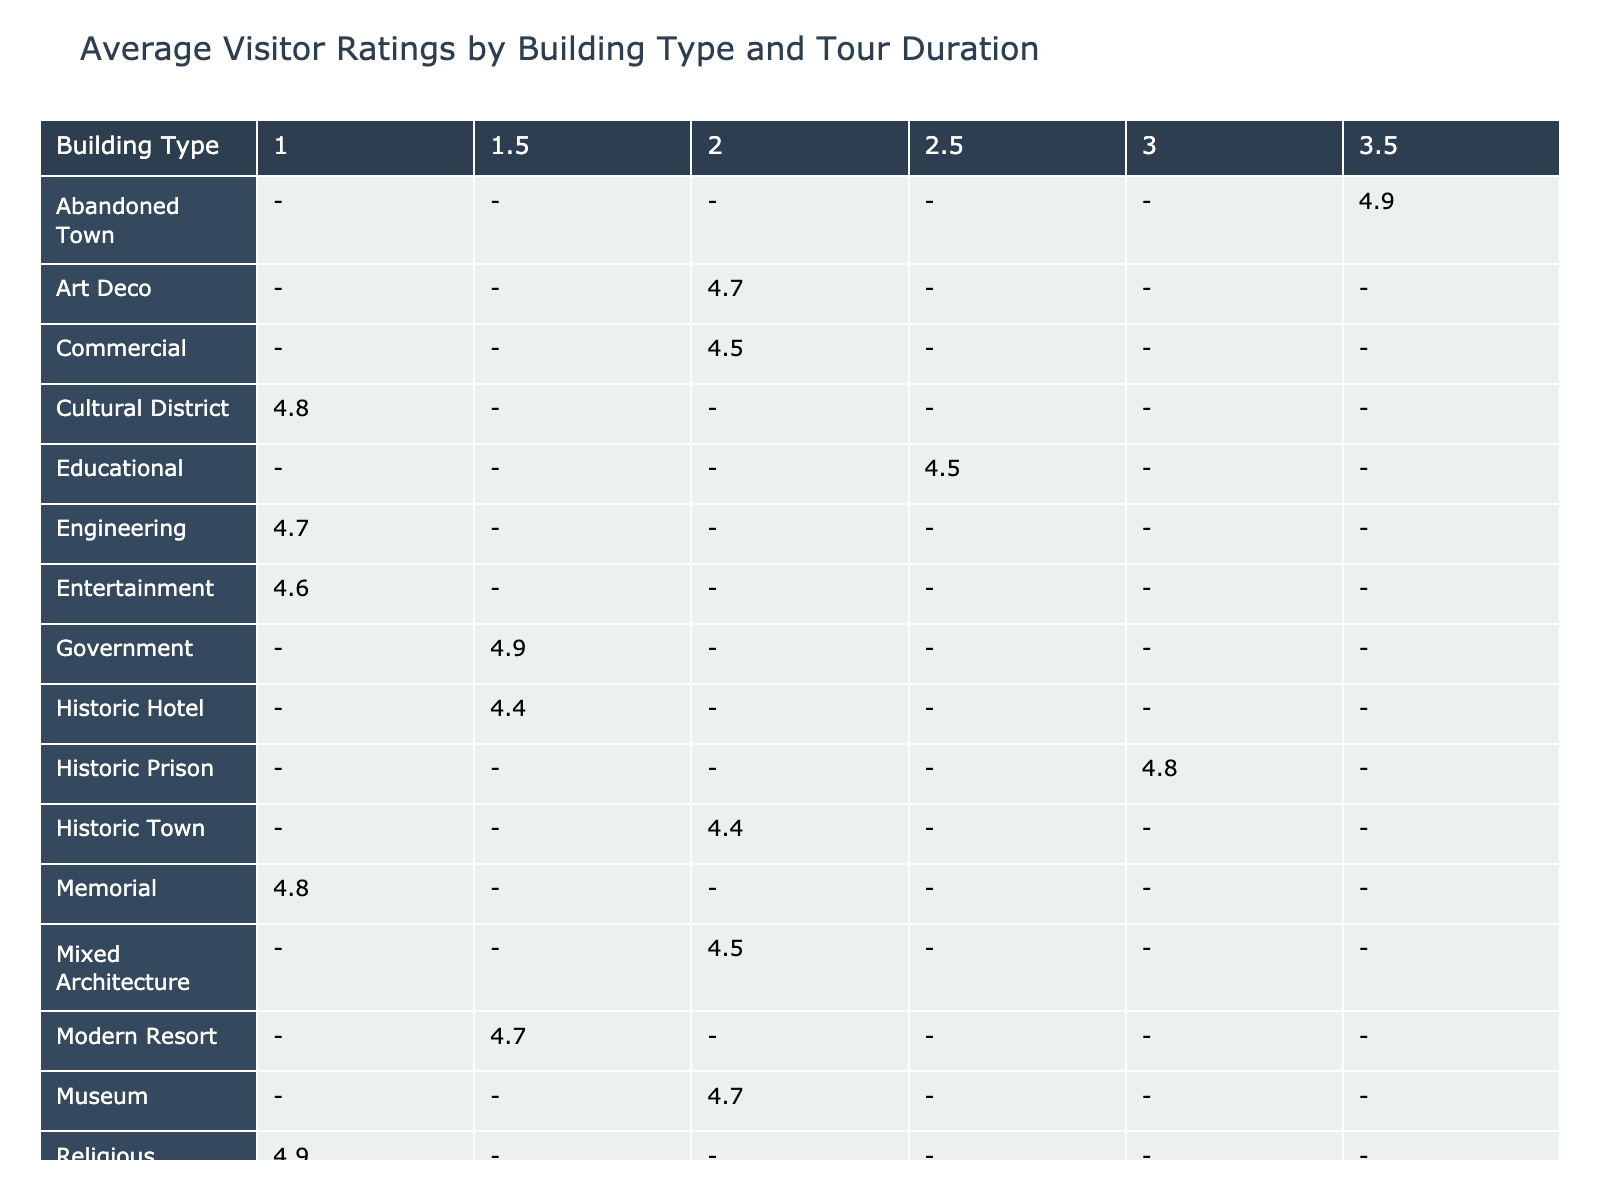What is the average visitor rating for the Idaho State Capitol Tour? The rating for the Idaho State Capitol Tour is provided in the table as 4.9.
Answer: 4.9 Which building type has the highest average rating for tours lasting 1 hour? Scanning the row for each building type with a tour duration of 1 hour, the Idaho Falls Temple Grounds Tour has a rating of 4.9, which is higher than other ratings listed for 1 hour tours.
Answer: 4.9 How many total visitors attended the tours for the Historic Town building type? The Historic Town building type includes the Ketchum Mining Town Walk which had 10 visitors and no other tours fall into this category, so the total is simply 10.
Answer: 10 What is the difference in average visitor ratings between Resort Architecture and Government building types? The average rating for Resort Architecture (Sun Valley Lodge History Tour) is 4.6 and for Government (Idaho State Capitol Tour) is 4.9. The difference is 4.9 - 4.6 = 0.3.
Answer: 0.3 Is the average visitor rating for the Mixed Architecture building type higher than that of the Entertainment building type? The average rating for Mixed Architecture (Pocatello Historic Downtown Tour) is 4.5, and for Entertainment (Sandpoint Panida Theater Tour) it is 4.6. Since 4.5 is less than 4.6, the answer is no.
Answer: No What is the highest average visitor rating across all building types regardless of tour duration? Scanning through the table, we find the highest average visitor rating is 4.9, seen with both the Idaho State Capitol Tour and Idaho Falls Temple Grounds Tour.
Answer: 4.9 How many visitors participated in tours with a duration of 2.5 hours? The only tours listed with a duration of 2.5 hours are the University of Idaho Campus Tour (12 visitors) and Wallace Historic District Walk (14 visitors), giving a total of 12 + 14 = 26 visitors.
Answer: 26 Which building type offered the longest tour duration, and what was its average rating? The longest tour duration listed in the table is 3.5 hours for the Silver City Ghost Town Exploration, which has an average rating of 4.9.
Answer: 4.9, Silver City Ghost Town Exploration Are there any tours with an average rating below 4.3? By examining the ratings, the only tour with an average rating below 4.3 is the McCall Log Cabin Tour rated at 4.2. Therefore, the answer is yes.
Answer: Yes 